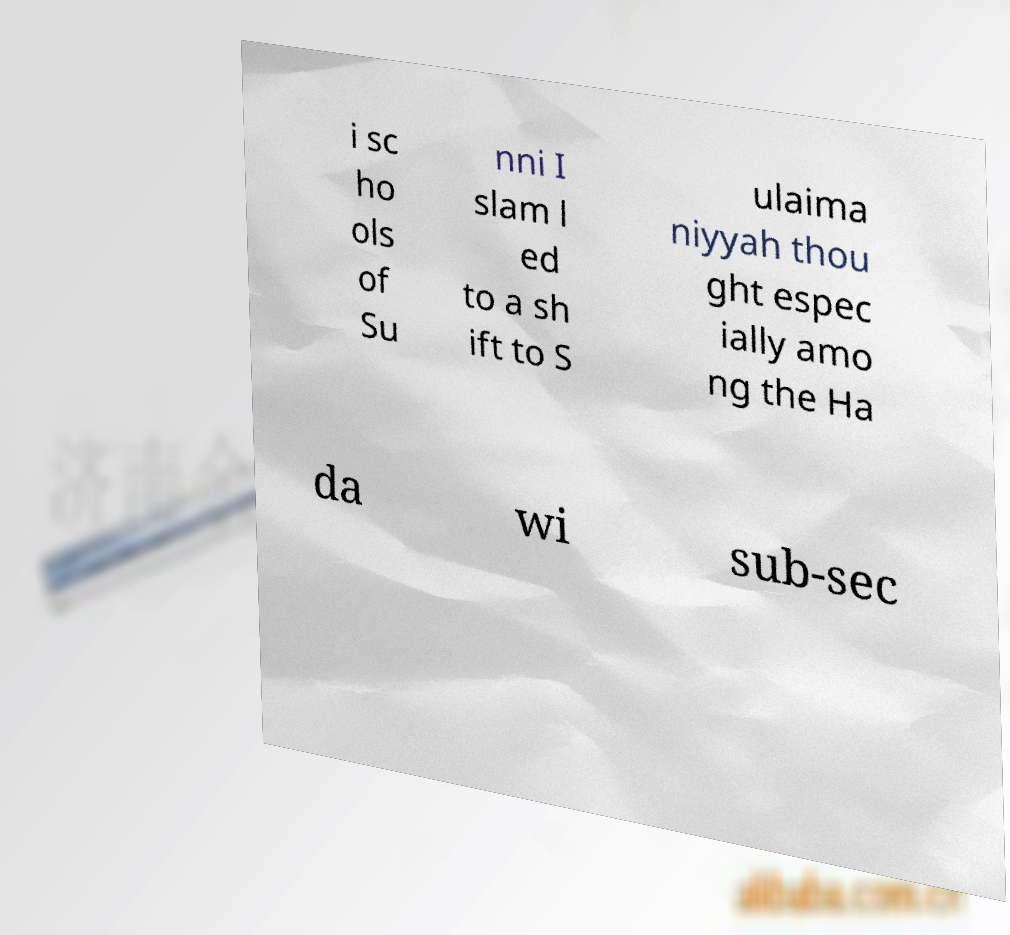Could you extract and type out the text from this image? i sc ho ols of Su nni I slam l ed to a sh ift to S ulaima niyyah thou ght espec ially amo ng the Ha da wi sub-sec 